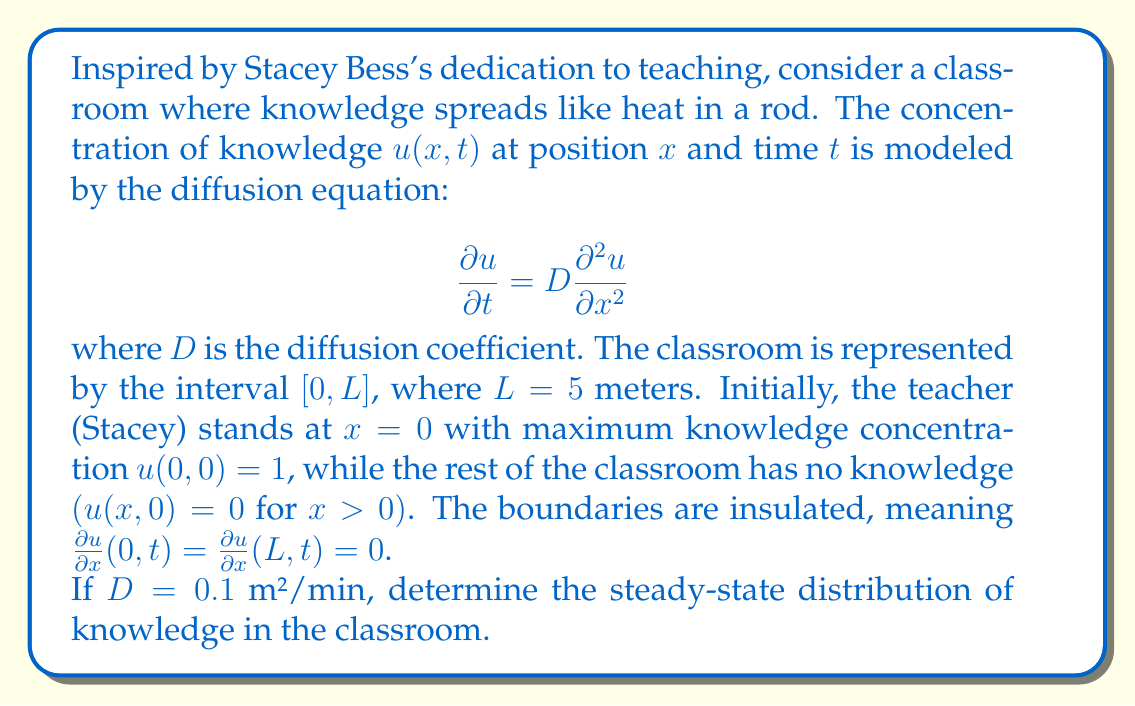Teach me how to tackle this problem. To solve this problem, we need to follow these steps:

1) First, we recognize that the steady-state solution is independent of time. This means $\frac{\partial u}{\partial t} = 0$.

2) Substituting this into our diffusion equation:

   $$0 = D\frac{\partial^2 u}{\partial x^2}$$

3) This simplifies to:

   $$\frac{\partial^2 u}{\partial x^2} = 0$$

4) Integrating twice with respect to $x$:

   $$u(x) = Ax + B$$

   where $A$ and $B$ are constants to be determined.

5) Now we apply the boundary conditions. The insulated boundaries mean:

   $$\frac{\partial u}{\partial x}(0,t) = \frac{\partial u}{\partial x}(L,t) = 0$$

6) Taking the derivative of our solution:

   $$\frac{du}{dx} = A$$

7) Applying the boundary conditions:

   $$A = 0$$

8) This means our steady-state solution is a constant:

   $$u(x) = B$$

9) To determine $B$, we need to use the principle of conservation of knowledge. The total amount of knowledge at the beginning (when it was all concentrated at $x=0$) should equal the total amount at steady state:

   $$\int_0^L u(x,0) dx = \int_0^L u(x,\infty) dx$$

   $$1 \cdot 0 + 0 \cdot L = B \cdot L$$

   $$B = \frac{1}{L} = \frac{1}{5}$$

Therefore, the steady-state distribution of knowledge is a constant value of $\frac{1}{5}$ throughout the classroom.
Answer: The steady-state distribution of knowledge in the classroom is $u(x) = \frac{1}{5}$ for all $x$ in $[0,L]$. 